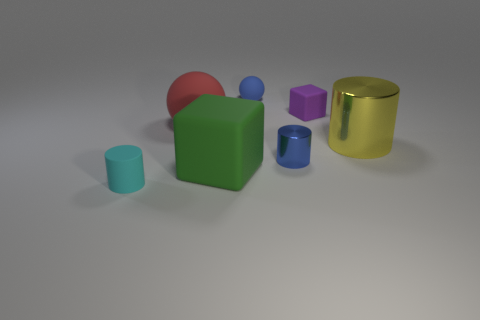The tiny sphere that is the same material as the small purple cube is what color?
Your response must be concise. Blue. Are there fewer purple matte things that are in front of the green cube than large red rubber spheres?
Keep it short and to the point. Yes. What is the size of the blue thing behind the metallic object behind the tiny blue object that is right of the tiny matte sphere?
Offer a very short reply. Small. Is the blue object behind the yellow metal thing made of the same material as the large block?
Keep it short and to the point. Yes. What material is the small cylinder that is the same color as the small rubber sphere?
Offer a very short reply. Metal. How many objects are big red things or green metal cylinders?
Offer a terse response. 1. The purple thing that is the same shape as the green object is what size?
Provide a short and direct response. Small. How many other objects are the same color as the big shiny cylinder?
Provide a succinct answer. 0. How many blocks are either blue rubber things or yellow things?
Provide a succinct answer. 0. The big matte thing in front of the cylinder to the right of the tiny purple object is what color?
Offer a very short reply. Green. 